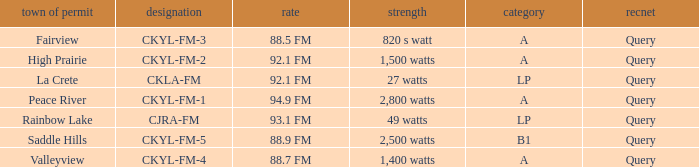What is the City of license with a 88.7 fm frequency Valleyview. 